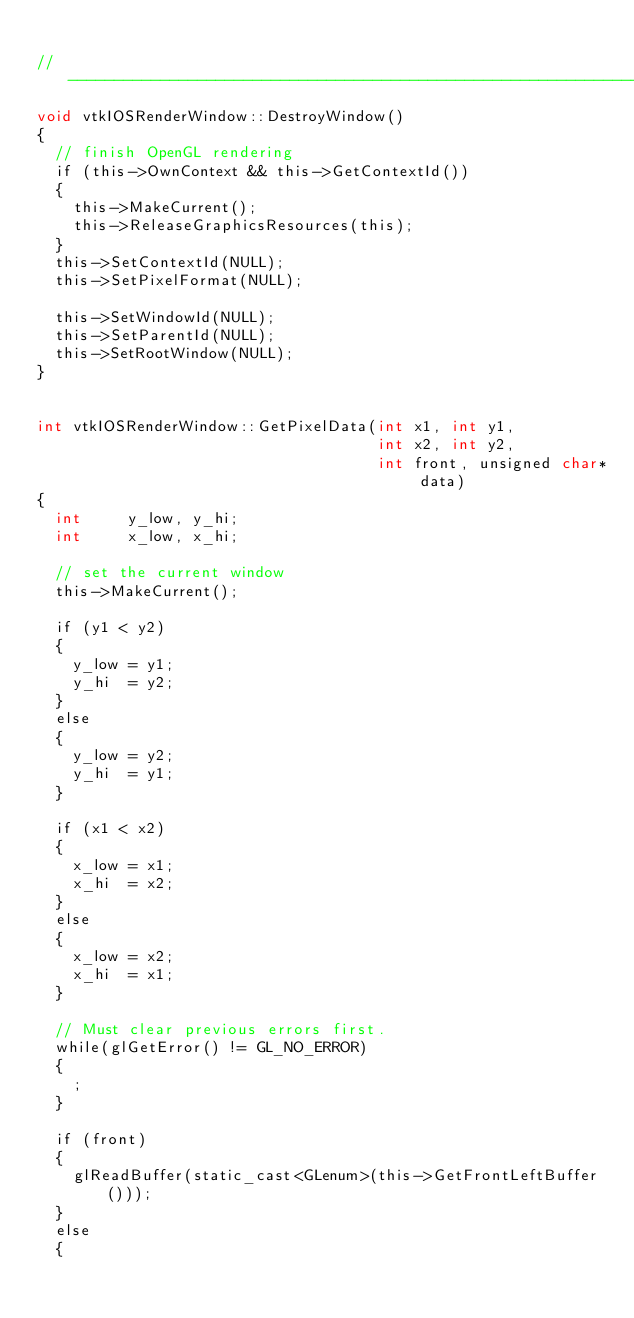Convert code to text. <code><loc_0><loc_0><loc_500><loc_500><_ObjectiveC_>
//----------------------------------------------------------------------------
void vtkIOSRenderWindow::DestroyWindow()
{
  // finish OpenGL rendering
  if (this->OwnContext && this->GetContextId())
  {
    this->MakeCurrent();
    this->ReleaseGraphicsResources(this);
  }
  this->SetContextId(NULL);
  this->SetPixelFormat(NULL);

  this->SetWindowId(NULL);
  this->SetParentId(NULL);
  this->SetRootWindow(NULL);
}


int vtkIOSRenderWindow::GetPixelData(int x1, int y1,
                                     int x2, int y2,
                                     int front, unsigned char* data)
{
  int     y_low, y_hi;
  int     x_low, x_hi;

  // set the current window
  this->MakeCurrent();

  if (y1 < y2)
  {
    y_low = y1;
    y_hi  = y2;
  }
  else
  {
    y_low = y2;
    y_hi  = y1;
  }

  if (x1 < x2)
  {
    x_low = x1;
    x_hi  = x2;
  }
  else
  {
    x_low = x2;
    x_hi  = x1;
  }

  // Must clear previous errors first.
  while(glGetError() != GL_NO_ERROR)
  {
    ;
  }

  if (front)
  {
    glReadBuffer(static_cast<GLenum>(this->GetFrontLeftBuffer()));
  }
  else
  {</code> 